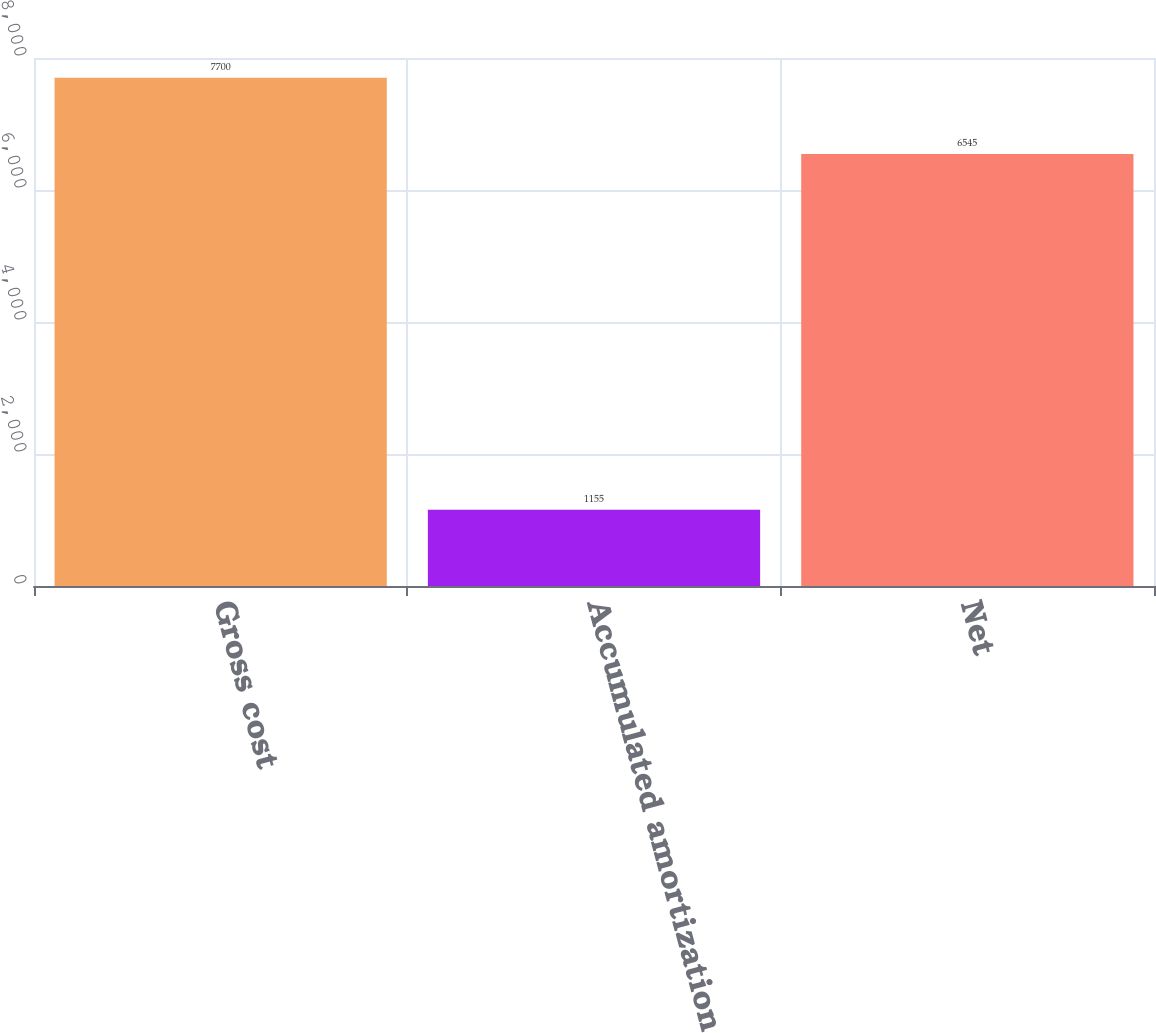<chart> <loc_0><loc_0><loc_500><loc_500><bar_chart><fcel>Gross cost<fcel>Accumulated amortization<fcel>Net<nl><fcel>7700<fcel>1155<fcel>6545<nl></chart> 